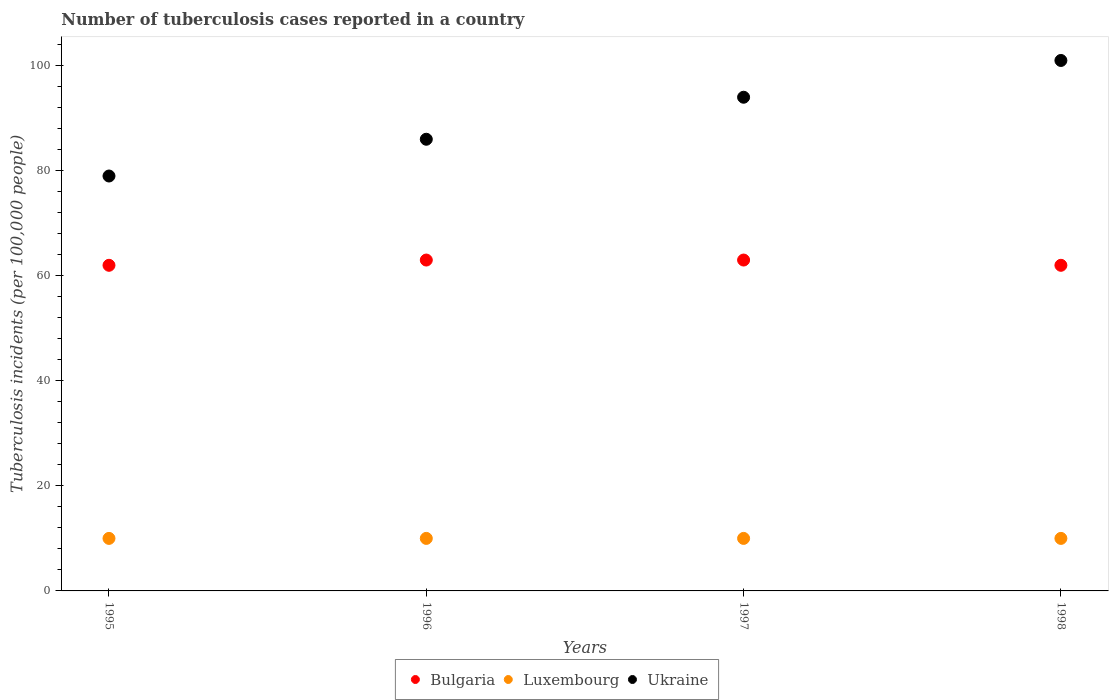Is the number of dotlines equal to the number of legend labels?
Make the answer very short. Yes. What is the number of tuberculosis cases reported in in Ukraine in 1996?
Provide a short and direct response. 86. Across all years, what is the maximum number of tuberculosis cases reported in in Bulgaria?
Give a very brief answer. 63. Across all years, what is the minimum number of tuberculosis cases reported in in Bulgaria?
Give a very brief answer. 62. In which year was the number of tuberculosis cases reported in in Bulgaria minimum?
Provide a short and direct response. 1995. What is the difference between the number of tuberculosis cases reported in in Ukraine in 1995 and that in 1997?
Give a very brief answer. -15. What is the difference between the number of tuberculosis cases reported in in Bulgaria in 1995 and the number of tuberculosis cases reported in in Luxembourg in 1996?
Provide a succinct answer. 52. In how many years, is the number of tuberculosis cases reported in in Bulgaria greater than 72?
Keep it short and to the point. 0. What is the ratio of the number of tuberculosis cases reported in in Ukraine in 1995 to that in 1996?
Keep it short and to the point. 0.92. Is the number of tuberculosis cases reported in in Luxembourg in 1995 less than that in 1997?
Give a very brief answer. No. What is the difference between the highest and the second highest number of tuberculosis cases reported in in Ukraine?
Make the answer very short. 7. What is the difference between the highest and the lowest number of tuberculosis cases reported in in Ukraine?
Give a very brief answer. 22. In how many years, is the number of tuberculosis cases reported in in Bulgaria greater than the average number of tuberculosis cases reported in in Bulgaria taken over all years?
Your response must be concise. 2. Is the sum of the number of tuberculosis cases reported in in Ukraine in 1995 and 1996 greater than the maximum number of tuberculosis cases reported in in Bulgaria across all years?
Ensure brevity in your answer.  Yes. Is it the case that in every year, the sum of the number of tuberculosis cases reported in in Ukraine and number of tuberculosis cases reported in in Luxembourg  is greater than the number of tuberculosis cases reported in in Bulgaria?
Your answer should be compact. Yes. Is the number of tuberculosis cases reported in in Ukraine strictly less than the number of tuberculosis cases reported in in Luxembourg over the years?
Make the answer very short. No. What is the difference between two consecutive major ticks on the Y-axis?
Keep it short and to the point. 20. Are the values on the major ticks of Y-axis written in scientific E-notation?
Provide a short and direct response. No. Does the graph contain any zero values?
Your answer should be compact. No. Where does the legend appear in the graph?
Your answer should be very brief. Bottom center. How many legend labels are there?
Your answer should be compact. 3. What is the title of the graph?
Provide a short and direct response. Number of tuberculosis cases reported in a country. What is the label or title of the X-axis?
Your answer should be compact. Years. What is the label or title of the Y-axis?
Your answer should be very brief. Tuberculosis incidents (per 100,0 people). What is the Tuberculosis incidents (per 100,000 people) in Bulgaria in 1995?
Offer a very short reply. 62. What is the Tuberculosis incidents (per 100,000 people) in Ukraine in 1995?
Provide a succinct answer. 79. What is the Tuberculosis incidents (per 100,000 people) in Bulgaria in 1996?
Offer a terse response. 63. What is the Tuberculosis incidents (per 100,000 people) in Ukraine in 1996?
Offer a very short reply. 86. What is the Tuberculosis incidents (per 100,000 people) of Bulgaria in 1997?
Your response must be concise. 63. What is the Tuberculosis incidents (per 100,000 people) of Luxembourg in 1997?
Your answer should be very brief. 10. What is the Tuberculosis incidents (per 100,000 people) of Ukraine in 1997?
Your answer should be very brief. 94. What is the Tuberculosis incidents (per 100,000 people) in Bulgaria in 1998?
Your response must be concise. 62. What is the Tuberculosis incidents (per 100,000 people) in Ukraine in 1998?
Offer a very short reply. 101. Across all years, what is the maximum Tuberculosis incidents (per 100,000 people) in Luxembourg?
Your answer should be very brief. 10. Across all years, what is the maximum Tuberculosis incidents (per 100,000 people) of Ukraine?
Your answer should be compact. 101. Across all years, what is the minimum Tuberculosis incidents (per 100,000 people) in Bulgaria?
Make the answer very short. 62. Across all years, what is the minimum Tuberculosis incidents (per 100,000 people) in Luxembourg?
Offer a terse response. 10. Across all years, what is the minimum Tuberculosis incidents (per 100,000 people) in Ukraine?
Give a very brief answer. 79. What is the total Tuberculosis incidents (per 100,000 people) in Bulgaria in the graph?
Provide a succinct answer. 250. What is the total Tuberculosis incidents (per 100,000 people) in Luxembourg in the graph?
Keep it short and to the point. 40. What is the total Tuberculosis incidents (per 100,000 people) of Ukraine in the graph?
Offer a terse response. 360. What is the difference between the Tuberculosis incidents (per 100,000 people) of Bulgaria in 1995 and that in 1996?
Offer a very short reply. -1. What is the difference between the Tuberculosis incidents (per 100,000 people) in Luxembourg in 1995 and that in 1996?
Provide a short and direct response. 0. What is the difference between the Tuberculosis incidents (per 100,000 people) in Bulgaria in 1995 and that in 1998?
Provide a short and direct response. 0. What is the difference between the Tuberculosis incidents (per 100,000 people) in Luxembourg in 1995 and that in 1998?
Ensure brevity in your answer.  0. What is the difference between the Tuberculosis incidents (per 100,000 people) in Ukraine in 1995 and that in 1998?
Provide a short and direct response. -22. What is the difference between the Tuberculosis incidents (per 100,000 people) in Bulgaria in 1996 and that in 1997?
Give a very brief answer. 0. What is the difference between the Tuberculosis incidents (per 100,000 people) of Ukraine in 1996 and that in 1997?
Your answer should be compact. -8. What is the difference between the Tuberculosis incidents (per 100,000 people) in Luxembourg in 1997 and that in 1998?
Your response must be concise. 0. What is the difference between the Tuberculosis incidents (per 100,000 people) of Luxembourg in 1995 and the Tuberculosis incidents (per 100,000 people) of Ukraine in 1996?
Give a very brief answer. -76. What is the difference between the Tuberculosis incidents (per 100,000 people) in Bulgaria in 1995 and the Tuberculosis incidents (per 100,000 people) in Luxembourg in 1997?
Your answer should be compact. 52. What is the difference between the Tuberculosis incidents (per 100,000 people) of Bulgaria in 1995 and the Tuberculosis incidents (per 100,000 people) of Ukraine in 1997?
Make the answer very short. -32. What is the difference between the Tuberculosis incidents (per 100,000 people) in Luxembourg in 1995 and the Tuberculosis incidents (per 100,000 people) in Ukraine in 1997?
Keep it short and to the point. -84. What is the difference between the Tuberculosis incidents (per 100,000 people) in Bulgaria in 1995 and the Tuberculosis incidents (per 100,000 people) in Luxembourg in 1998?
Your answer should be compact. 52. What is the difference between the Tuberculosis incidents (per 100,000 people) in Bulgaria in 1995 and the Tuberculosis incidents (per 100,000 people) in Ukraine in 1998?
Keep it short and to the point. -39. What is the difference between the Tuberculosis incidents (per 100,000 people) in Luxembourg in 1995 and the Tuberculosis incidents (per 100,000 people) in Ukraine in 1998?
Provide a succinct answer. -91. What is the difference between the Tuberculosis incidents (per 100,000 people) of Bulgaria in 1996 and the Tuberculosis incidents (per 100,000 people) of Ukraine in 1997?
Make the answer very short. -31. What is the difference between the Tuberculosis incidents (per 100,000 people) of Luxembourg in 1996 and the Tuberculosis incidents (per 100,000 people) of Ukraine in 1997?
Keep it short and to the point. -84. What is the difference between the Tuberculosis incidents (per 100,000 people) of Bulgaria in 1996 and the Tuberculosis incidents (per 100,000 people) of Luxembourg in 1998?
Make the answer very short. 53. What is the difference between the Tuberculosis incidents (per 100,000 people) of Bulgaria in 1996 and the Tuberculosis incidents (per 100,000 people) of Ukraine in 1998?
Your answer should be very brief. -38. What is the difference between the Tuberculosis incidents (per 100,000 people) of Luxembourg in 1996 and the Tuberculosis incidents (per 100,000 people) of Ukraine in 1998?
Keep it short and to the point. -91. What is the difference between the Tuberculosis incidents (per 100,000 people) of Bulgaria in 1997 and the Tuberculosis incidents (per 100,000 people) of Luxembourg in 1998?
Your answer should be very brief. 53. What is the difference between the Tuberculosis incidents (per 100,000 people) in Bulgaria in 1997 and the Tuberculosis incidents (per 100,000 people) in Ukraine in 1998?
Provide a succinct answer. -38. What is the difference between the Tuberculosis incidents (per 100,000 people) in Luxembourg in 1997 and the Tuberculosis incidents (per 100,000 people) in Ukraine in 1998?
Give a very brief answer. -91. What is the average Tuberculosis incidents (per 100,000 people) of Bulgaria per year?
Offer a terse response. 62.5. What is the average Tuberculosis incidents (per 100,000 people) in Luxembourg per year?
Offer a very short reply. 10. In the year 1995, what is the difference between the Tuberculosis incidents (per 100,000 people) of Bulgaria and Tuberculosis incidents (per 100,000 people) of Ukraine?
Make the answer very short. -17. In the year 1995, what is the difference between the Tuberculosis incidents (per 100,000 people) of Luxembourg and Tuberculosis incidents (per 100,000 people) of Ukraine?
Your answer should be very brief. -69. In the year 1996, what is the difference between the Tuberculosis incidents (per 100,000 people) of Bulgaria and Tuberculosis incidents (per 100,000 people) of Luxembourg?
Ensure brevity in your answer.  53. In the year 1996, what is the difference between the Tuberculosis incidents (per 100,000 people) in Bulgaria and Tuberculosis incidents (per 100,000 people) in Ukraine?
Your response must be concise. -23. In the year 1996, what is the difference between the Tuberculosis incidents (per 100,000 people) of Luxembourg and Tuberculosis incidents (per 100,000 people) of Ukraine?
Offer a terse response. -76. In the year 1997, what is the difference between the Tuberculosis incidents (per 100,000 people) in Bulgaria and Tuberculosis incidents (per 100,000 people) in Luxembourg?
Ensure brevity in your answer.  53. In the year 1997, what is the difference between the Tuberculosis incidents (per 100,000 people) of Bulgaria and Tuberculosis incidents (per 100,000 people) of Ukraine?
Offer a very short reply. -31. In the year 1997, what is the difference between the Tuberculosis incidents (per 100,000 people) of Luxembourg and Tuberculosis incidents (per 100,000 people) of Ukraine?
Offer a terse response. -84. In the year 1998, what is the difference between the Tuberculosis incidents (per 100,000 people) of Bulgaria and Tuberculosis incidents (per 100,000 people) of Ukraine?
Ensure brevity in your answer.  -39. In the year 1998, what is the difference between the Tuberculosis incidents (per 100,000 people) in Luxembourg and Tuberculosis incidents (per 100,000 people) in Ukraine?
Your answer should be very brief. -91. What is the ratio of the Tuberculosis incidents (per 100,000 people) in Bulgaria in 1995 to that in 1996?
Your answer should be very brief. 0.98. What is the ratio of the Tuberculosis incidents (per 100,000 people) in Luxembourg in 1995 to that in 1996?
Offer a terse response. 1. What is the ratio of the Tuberculosis incidents (per 100,000 people) of Ukraine in 1995 to that in 1996?
Offer a terse response. 0.92. What is the ratio of the Tuberculosis incidents (per 100,000 people) in Bulgaria in 1995 to that in 1997?
Offer a terse response. 0.98. What is the ratio of the Tuberculosis incidents (per 100,000 people) in Luxembourg in 1995 to that in 1997?
Offer a terse response. 1. What is the ratio of the Tuberculosis incidents (per 100,000 people) in Ukraine in 1995 to that in 1997?
Provide a short and direct response. 0.84. What is the ratio of the Tuberculosis incidents (per 100,000 people) of Ukraine in 1995 to that in 1998?
Your answer should be compact. 0.78. What is the ratio of the Tuberculosis incidents (per 100,000 people) in Bulgaria in 1996 to that in 1997?
Provide a short and direct response. 1. What is the ratio of the Tuberculosis incidents (per 100,000 people) in Luxembourg in 1996 to that in 1997?
Offer a very short reply. 1. What is the ratio of the Tuberculosis incidents (per 100,000 people) in Ukraine in 1996 to that in 1997?
Your answer should be very brief. 0.91. What is the ratio of the Tuberculosis incidents (per 100,000 people) in Bulgaria in 1996 to that in 1998?
Offer a terse response. 1.02. What is the ratio of the Tuberculosis incidents (per 100,000 people) in Ukraine in 1996 to that in 1998?
Give a very brief answer. 0.85. What is the ratio of the Tuberculosis incidents (per 100,000 people) in Bulgaria in 1997 to that in 1998?
Keep it short and to the point. 1.02. What is the ratio of the Tuberculosis incidents (per 100,000 people) in Luxembourg in 1997 to that in 1998?
Your answer should be very brief. 1. What is the ratio of the Tuberculosis incidents (per 100,000 people) of Ukraine in 1997 to that in 1998?
Ensure brevity in your answer.  0.93. What is the difference between the highest and the second highest Tuberculosis incidents (per 100,000 people) of Bulgaria?
Provide a short and direct response. 0. What is the difference between the highest and the second highest Tuberculosis incidents (per 100,000 people) of Ukraine?
Make the answer very short. 7. What is the difference between the highest and the lowest Tuberculosis incidents (per 100,000 people) of Ukraine?
Ensure brevity in your answer.  22. 